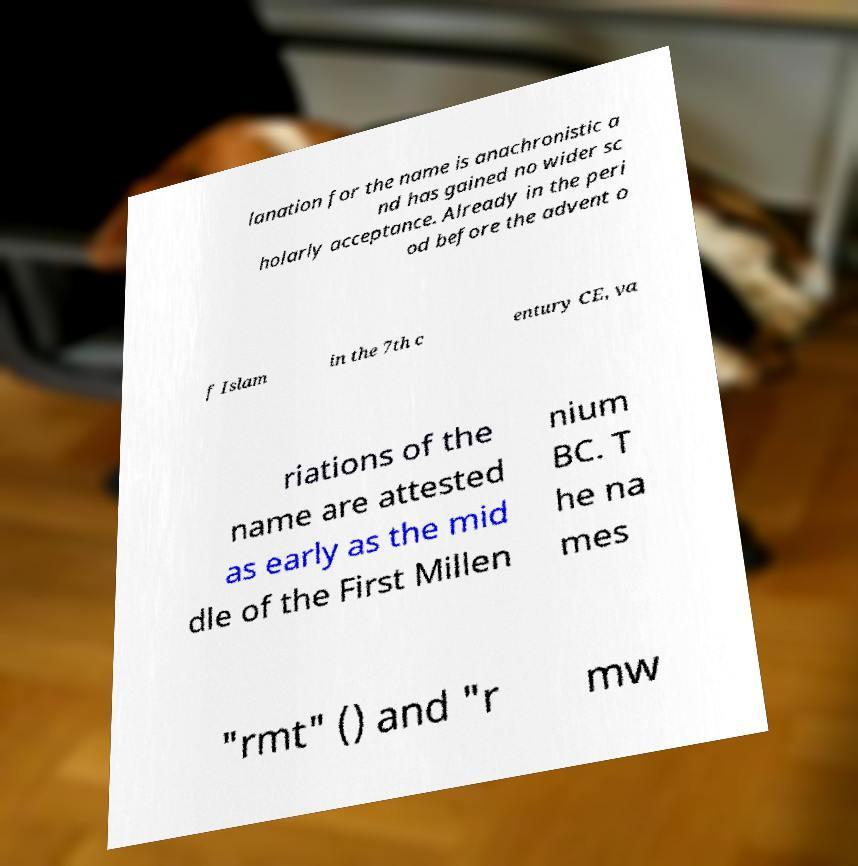Could you extract and type out the text from this image? lanation for the name is anachronistic a nd has gained no wider sc holarly acceptance. Already in the peri od before the advent o f Islam in the 7th c entury CE, va riations of the name are attested as early as the mid dle of the First Millen nium BC. T he na mes "rmt" () and "r mw 